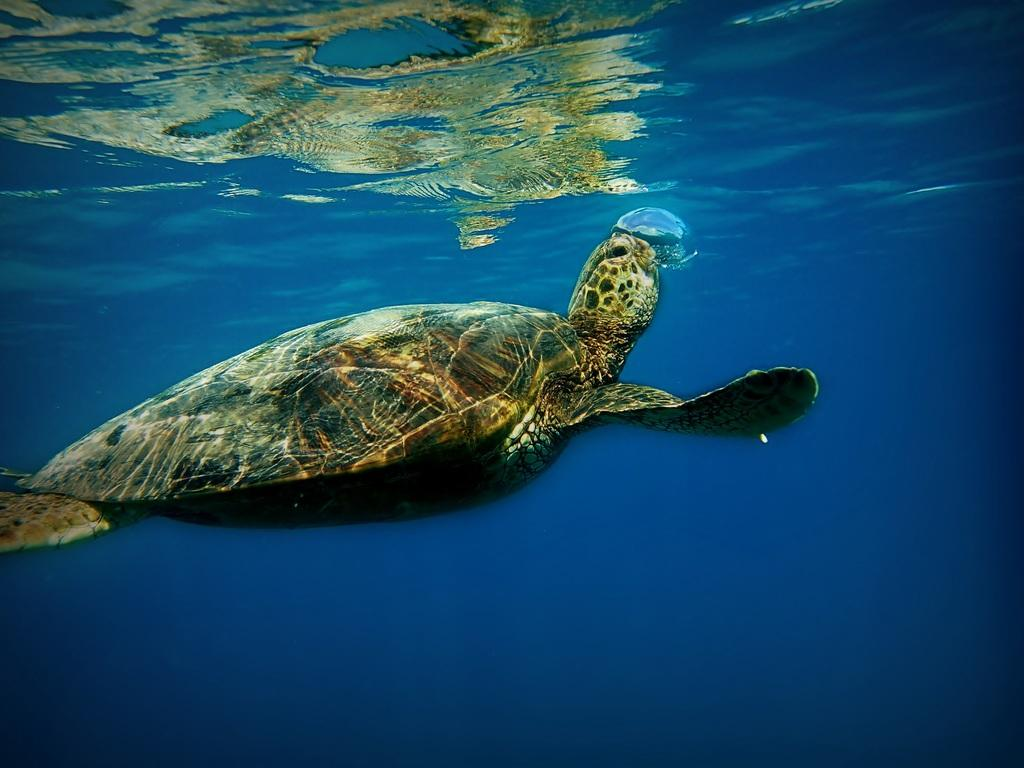What is depicted in the image? There is a picture of a tortoise in the image. Where is the tortoise located in the image? The tortoise is underwater. What colors can be seen on the tortoise? The tortoise is black and brown in color. What color is the water in the image? The water in the image is blue. What type of gun can be seen in the image? There is no gun present in the image; it features a picture of a tortoise underwater. How many songs can be heard playing in the background of the image? There is no audio or music present in the image, as it is a static picture of a tortoise underwater. 